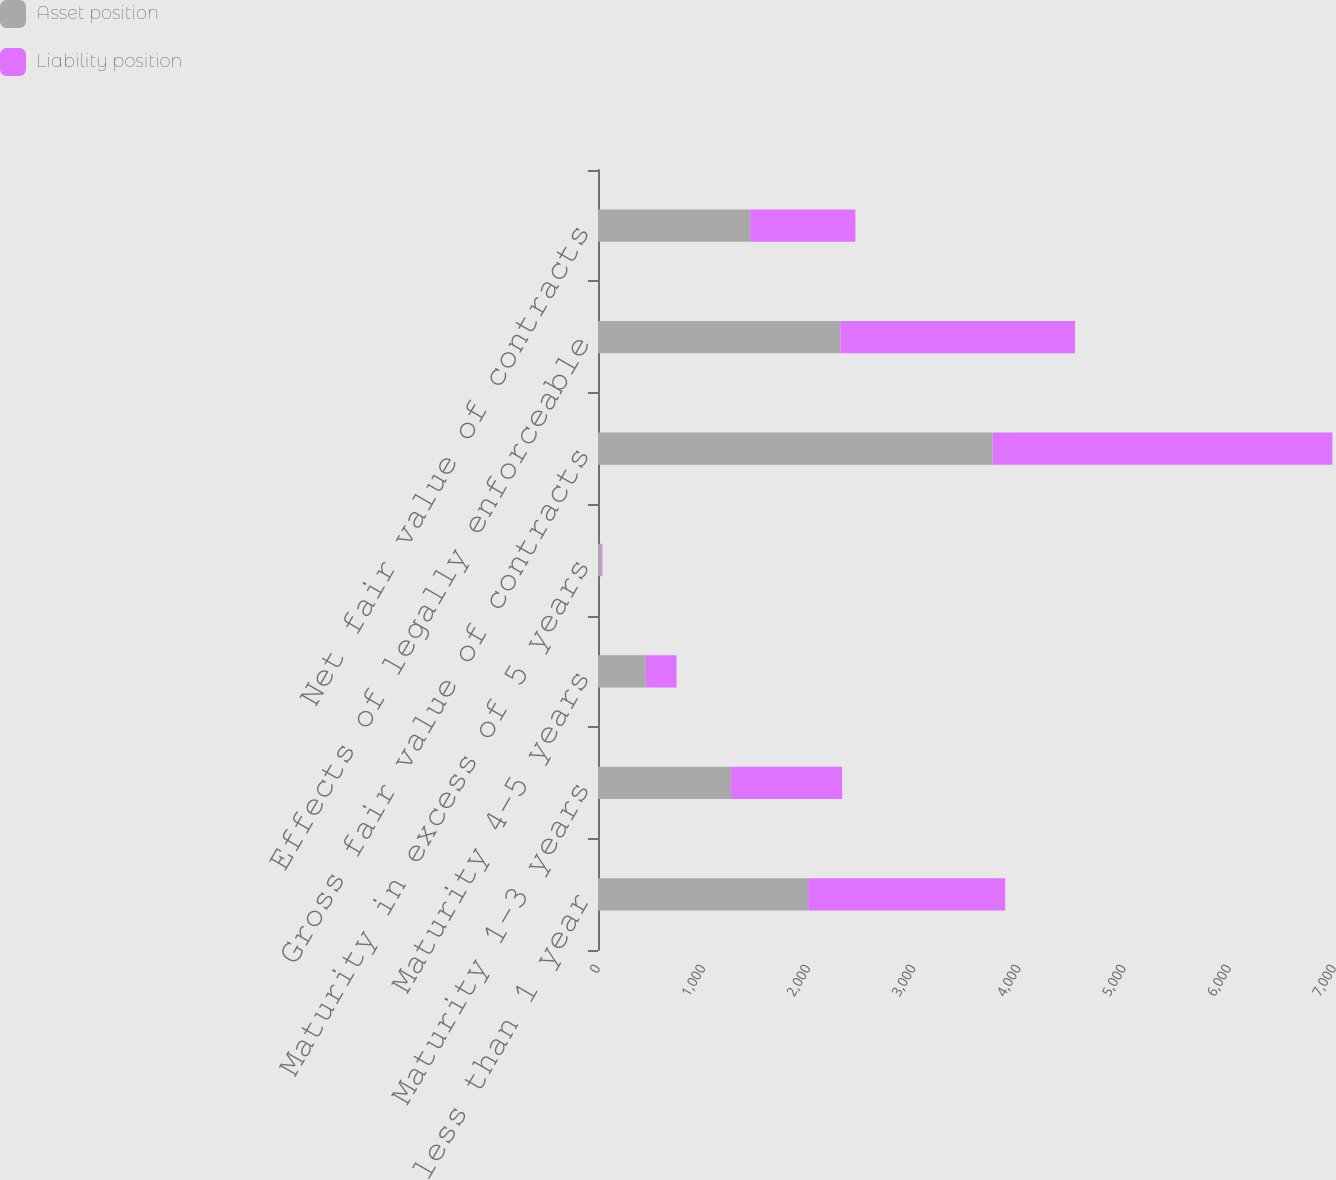<chart> <loc_0><loc_0><loc_500><loc_500><stacked_bar_chart><ecel><fcel>Maturity less than 1 year<fcel>Maturity 1-3 years<fcel>Maturity 4-5 years<fcel>Maturity in excess of 5 years<fcel>Gross fair value of contracts<fcel>Effects of legally enforceable<fcel>Net fair value of contracts<nl><fcel>Asset position<fcel>1999<fcel>1266<fcel>454<fcel>34<fcel>3753<fcel>2304<fcel>1449<nl><fcel>Liability position<fcel>1874<fcel>1056<fcel>293<fcel>9<fcel>3232<fcel>2233<fcel>999<nl></chart> 